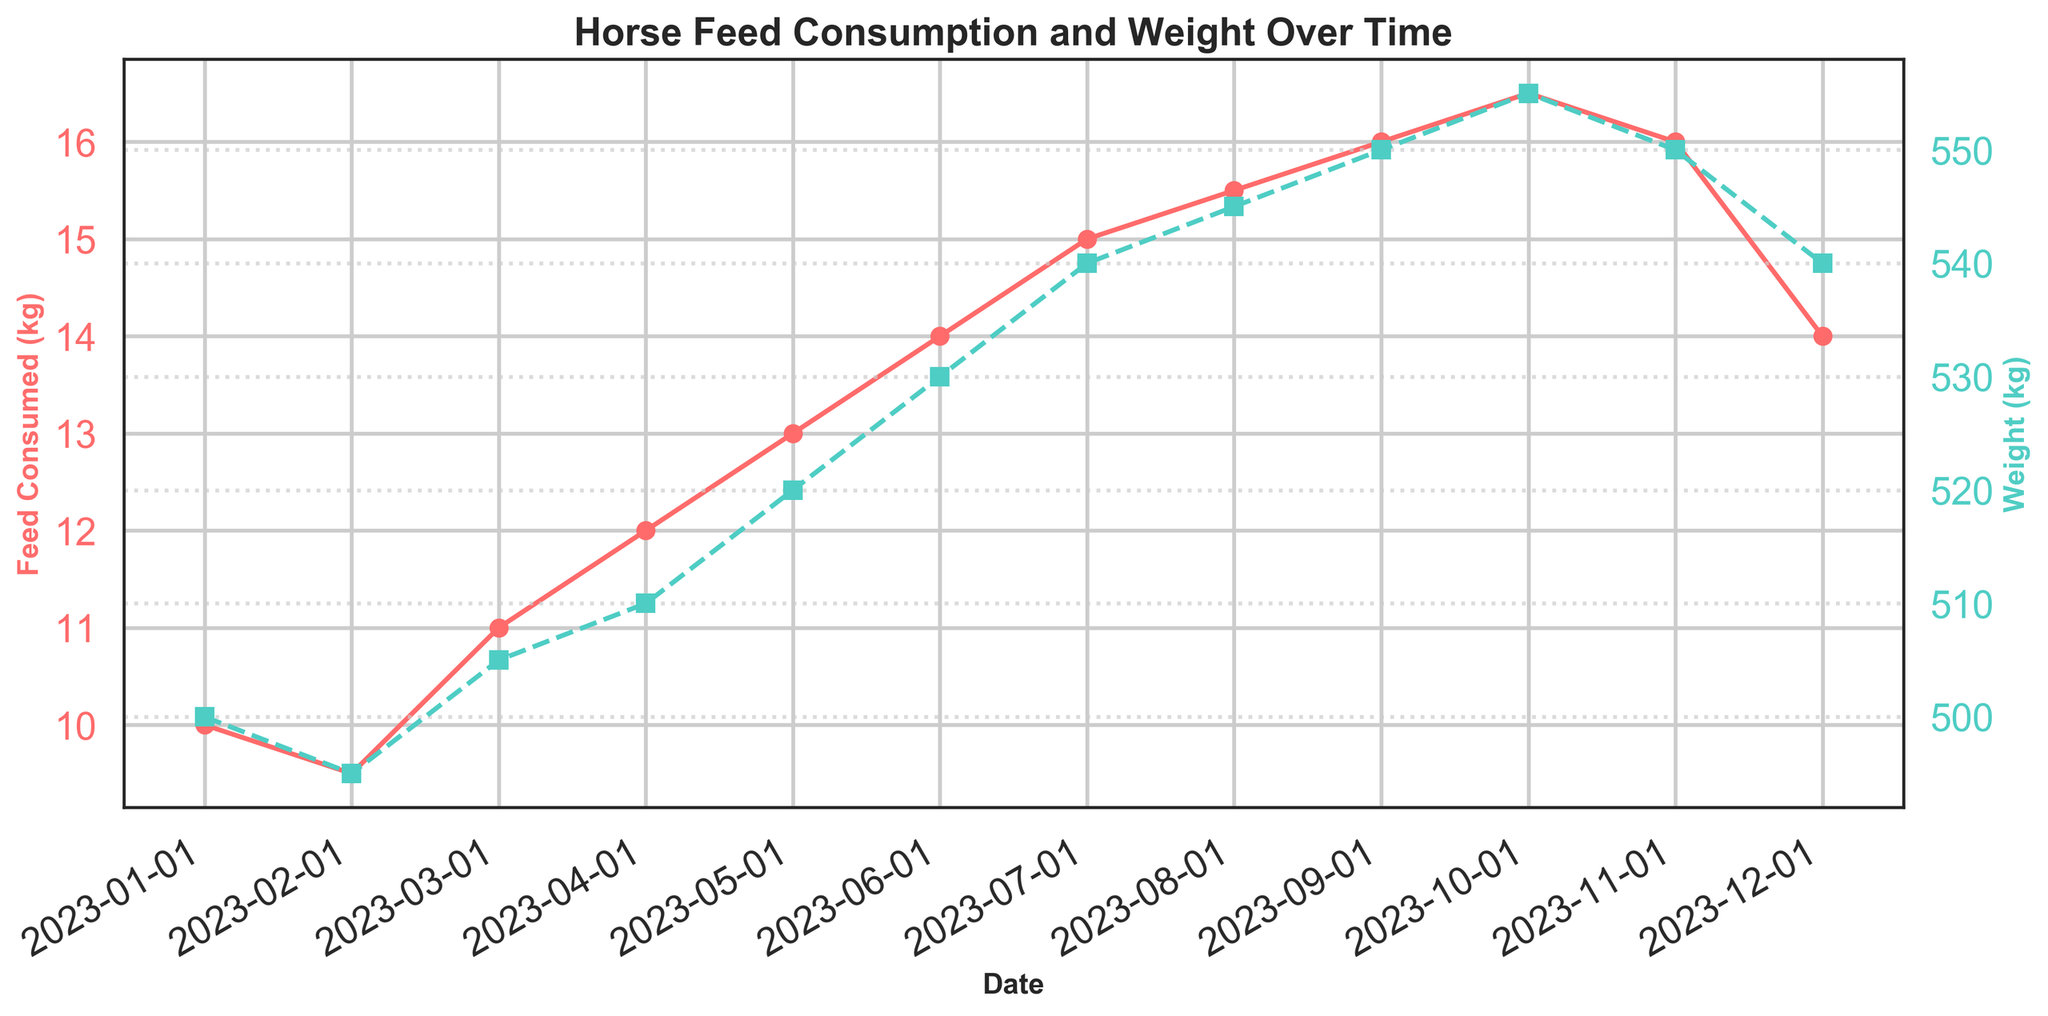what is the title of the figure? The title is located at the top of the figure, which summarizes the content of the plot.
Answer: Horse Feed Consumption and Weight Over Time How many data points are plotted for feed consumption? By looking at the plotted points on the feed consumption line (in orange), you can count them to determine the number of data points.
Answer: 12 What color is used for the line representing weight? By examining the twin axes, you can see the line color associated with weight. It is the second line on the plot.
Answer: Teal/Green During which month does the feed consumption reach its highest point? Identify the peak point on the 'Feed Consumed (kg)' line (orange) and see which month it corresponds to.
Answer: October What is the horse's weight in May? Locate May on the x-axis and follow it up to the 'Weight (kg)' line (teal/green), then refer to the y-axis on the right.
Answer: 520 kg In which month does the weight decrease after peaking? Find the maximum weight on the 'Weight (kg)' line (teal/green), then identify the next month with a lower value.
Answer: November What is the average feed consumed over the first quarter of the year? Add the feed values for Jan, Feb, and Mar (10 + 9.5 + 11), then divide by 3.
Answer: 10.17 kg How does the feed consumption in December compare to November? Compare the feed consumption values in December and November by looking at the end of the plot.
Answer: It decreases from 16 kg to 14 kg What is the overall trend in weight over the year? Observe the 'Weight (kg)' line (teal/green) to understand the general direction from the beginning to the end of the year.
Answer: Increasing trend Is there a month where the feed consumption remains the same as the previous month? Look for flat segments or repeated values on the 'Feed Consumed (kg)' line (orange).
Answer: No 